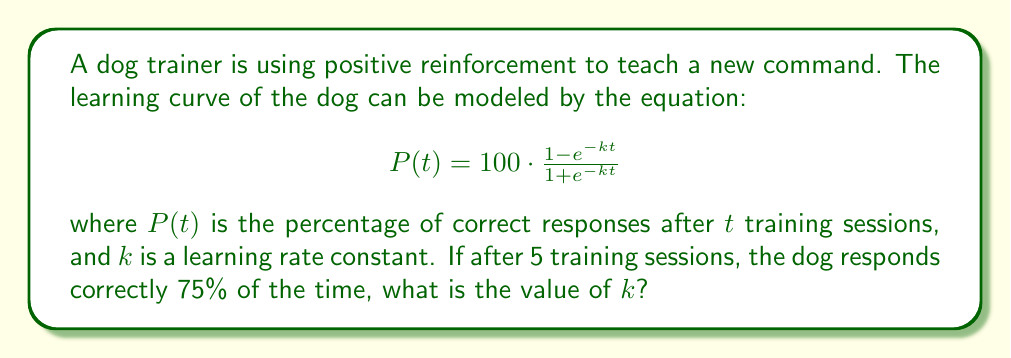Teach me how to tackle this problem. To solve this problem, we'll follow these steps:

1) We know that after 5 training sessions ($t = 5$), the dog responds correctly 75% of the time ($P(5) = 75$).

2) Let's substitute these values into our equation:

   $$75 = 100 \cdot \frac{1 - e^{-5k}}{1 + e^{-5k}}$$

3) Simplify the right side:

   $$75 = \frac{100 - 100e^{-5k}}{1 + e^{-5k}}$$

4) Multiply both sides by the denominator:

   $$75 + 75e^{-5k} = 100 - 100e^{-5k}$$

5) Rearrange terms:

   $$75 + 75e^{-5k} + 100e^{-5k} = 100$$
   $$75 + 175e^{-5k} = 100$$

6) Subtract 75 from both sides:

   $$175e^{-5k} = 25$$

7) Divide both sides by 175:

   $$e^{-5k} = \frac{1}{7}$$

8) Take the natural log of both sides:

   $$-5k = \ln(\frac{1}{7})$$

9) Divide both sides by -5:

   $$k = -\frac{1}{5}\ln(\frac{1}{7}) = \frac{1}{5}\ln(7)$$

10) Calculate the final value:

    $$k \approx 0.3866$$
Answer: $k \approx 0.3866$ 